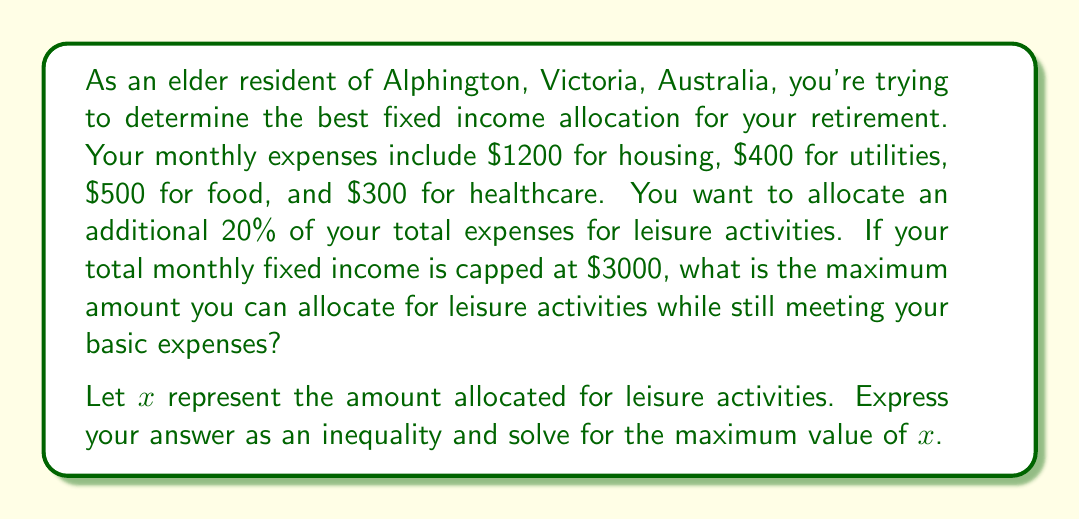Help me with this question. Let's approach this step-by-step:

1) First, let's sum up the basic expenses:
   $1200 + 400 + 500 + 300 = 2400$

2) Now, we know that the leisure activities should be 20% of the total expenses. We can express this as an equation:
   $x = 0.2(2400 + x)$

3) Let's solve this equation:
   $x = 480 + 0.2x$
   $0.8x = 480$
   $x = 600$

4) So, ideally, we would allocate $600 for leisure activities. However, we need to check if this fits within our budget constraint.

5) Total expenses including leisure:
   $2400 + 600 = 3000$

6) This equals our maximum monthly fixed income, so it fits perfectly.

7) To express this as an inequality:
   $2400 + x \leq 3000$
   $x \leq 600$

Therefore, the maximum amount that can be allocated for leisure activities while still meeting basic expenses is $600.
Answer: $x \leq 600$, with the maximum value of $x$ being $600$. 